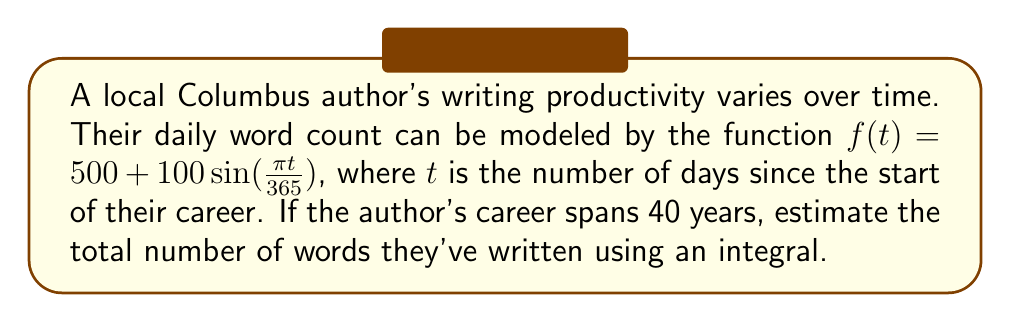Help me with this question. To solve this problem, we'll follow these steps:

1) The function $f(t) = 500 + 100\sin(\frac{\pi t}{365})$ represents the daily word count.

2) To find the total words written over 40 years, we need to integrate this function from $t=0$ to $t=40*365$ (as there are 365 days in a year).

3) Set up the integral:

   $$\int_0^{40*365} (500 + 100\sin(\frac{\pi t}{365})) dt$$

4) Integrate:
   
   $$\left[500t - \frac{100*365}{\pi}\cos(\frac{\pi t}{365})\right]_0^{40*365}$$

5) Evaluate the integral:

   $$\left[500(40*365) - \frac{100*365}{\pi}\cos(\frac{40\pi*365}{365})\right] - \left[0 - \frac{100*365}{\pi}\cos(0)\right]$$

6) Simplify:
   
   $$500(40*365) - \frac{100*365}{\pi}\cos(40\pi) + \frac{100*365}{\pi}$$

7) Calculate:
   
   $$7,300,000 - 0 + 11,624 = 7,311,624$$

Therefore, the author wrote approximately 7,311,624 words over their 40-year career.
Answer: 7,311,624 words 